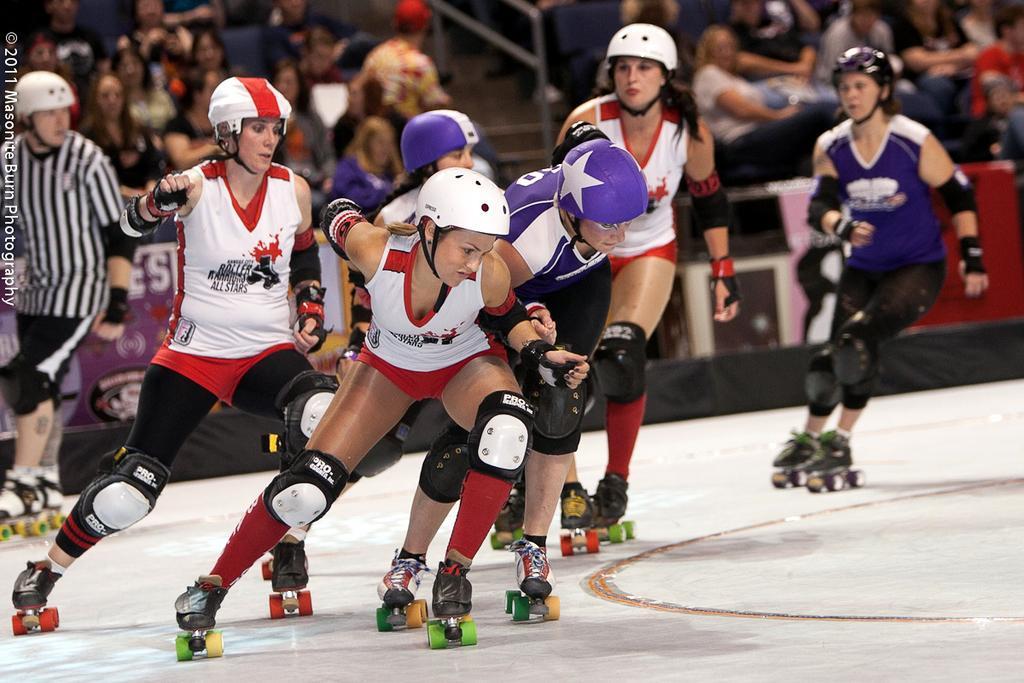Can you describe this image briefly? This image consists of women wearing skates and helmets are skating. At the bottom, there is ground. In the background, there are many people sitting. It looks like a indoor stadium. 